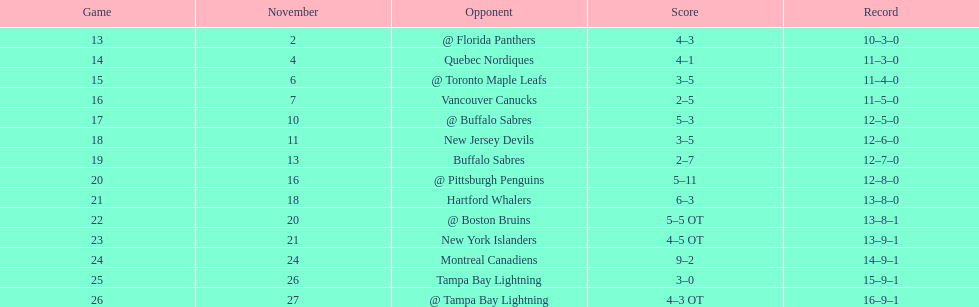Did the tampa bay lightning have the least amount of wins? Yes. 